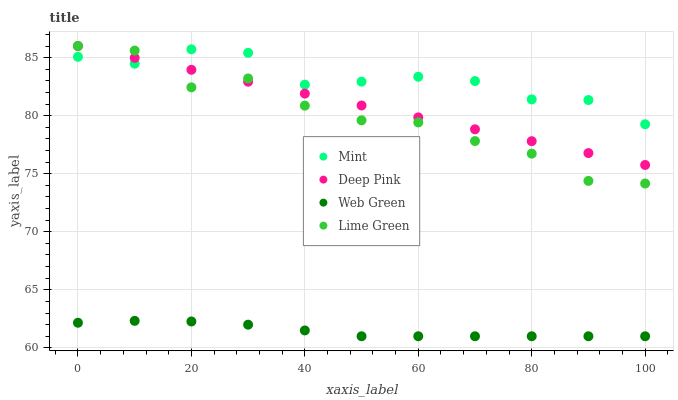Does Web Green have the minimum area under the curve?
Answer yes or no. Yes. Does Mint have the maximum area under the curve?
Answer yes or no. Yes. Does Deep Pink have the minimum area under the curve?
Answer yes or no. No. Does Deep Pink have the maximum area under the curve?
Answer yes or no. No. Is Deep Pink the smoothest?
Answer yes or no. Yes. Is Lime Green the roughest?
Answer yes or no. Yes. Is Mint the smoothest?
Answer yes or no. No. Is Mint the roughest?
Answer yes or no. No. Does Web Green have the lowest value?
Answer yes or no. Yes. Does Deep Pink have the lowest value?
Answer yes or no. No. Does Deep Pink have the highest value?
Answer yes or no. Yes. Does Mint have the highest value?
Answer yes or no. No. Is Web Green less than Mint?
Answer yes or no. Yes. Is Lime Green greater than Web Green?
Answer yes or no. Yes. Does Lime Green intersect Mint?
Answer yes or no. Yes. Is Lime Green less than Mint?
Answer yes or no. No. Is Lime Green greater than Mint?
Answer yes or no. No. Does Web Green intersect Mint?
Answer yes or no. No. 